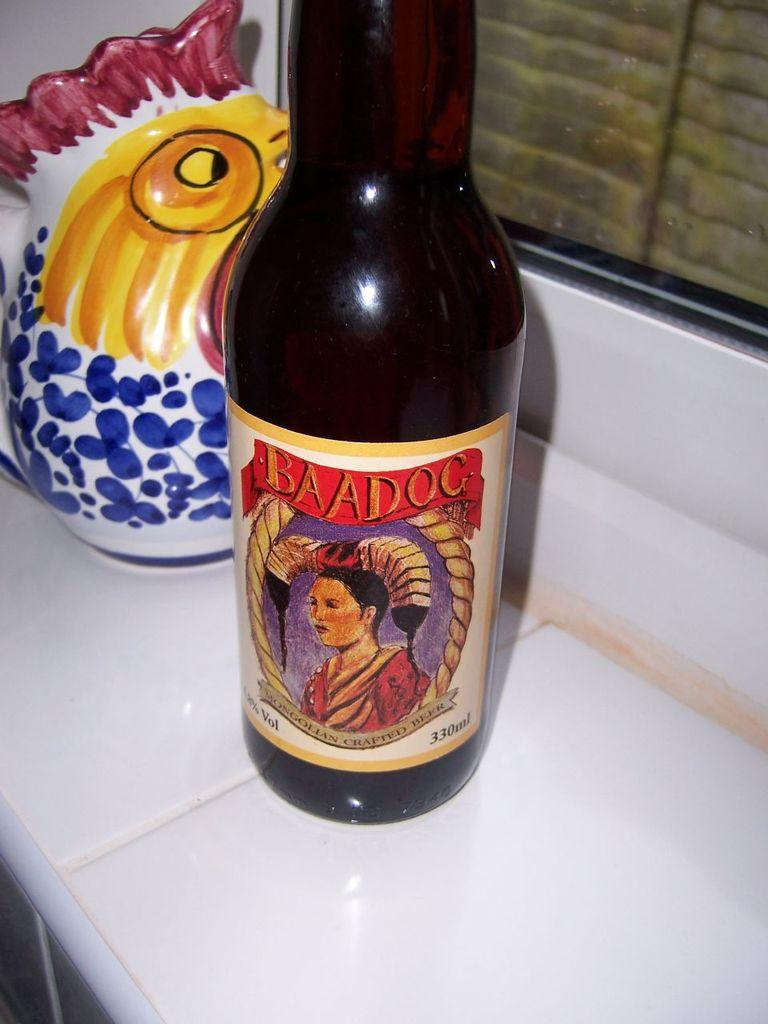<image>
Write a terse but informative summary of the picture. A bottle of Baadog Mongolian crafted beer next to a ceramic chicken. 